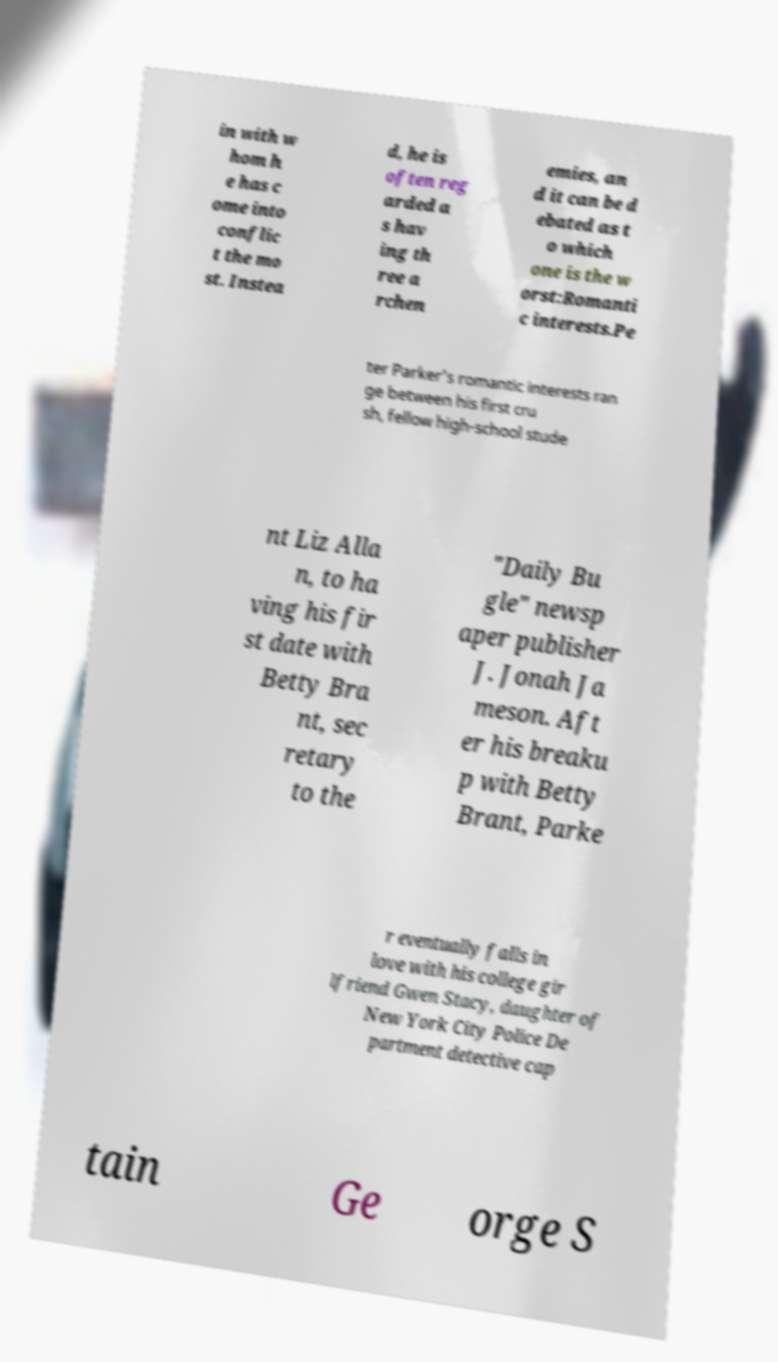Please read and relay the text visible in this image. What does it say? in with w hom h e has c ome into conflic t the mo st. Instea d, he is often reg arded a s hav ing th ree a rchen emies, an d it can be d ebated as t o which one is the w orst:Romanti c interests.Pe ter Parker's romantic interests ran ge between his first cru sh, fellow high-school stude nt Liz Alla n, to ha ving his fir st date with Betty Bra nt, sec retary to the "Daily Bu gle" newsp aper publisher J. Jonah Ja meson. Aft er his breaku p with Betty Brant, Parke r eventually falls in love with his college gir lfriend Gwen Stacy, daughter of New York City Police De partment detective cap tain Ge orge S 